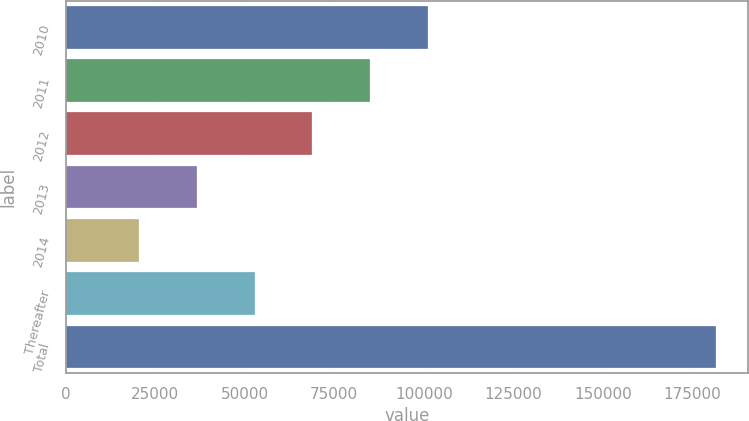Convert chart to OTSL. <chart><loc_0><loc_0><loc_500><loc_500><bar_chart><fcel>2010<fcel>2011<fcel>2012<fcel>2013<fcel>2014<fcel>Thereafter<fcel>Total<nl><fcel>101095<fcel>84988.2<fcel>68881.4<fcel>36667.8<fcel>20561<fcel>52774.6<fcel>181629<nl></chart> 